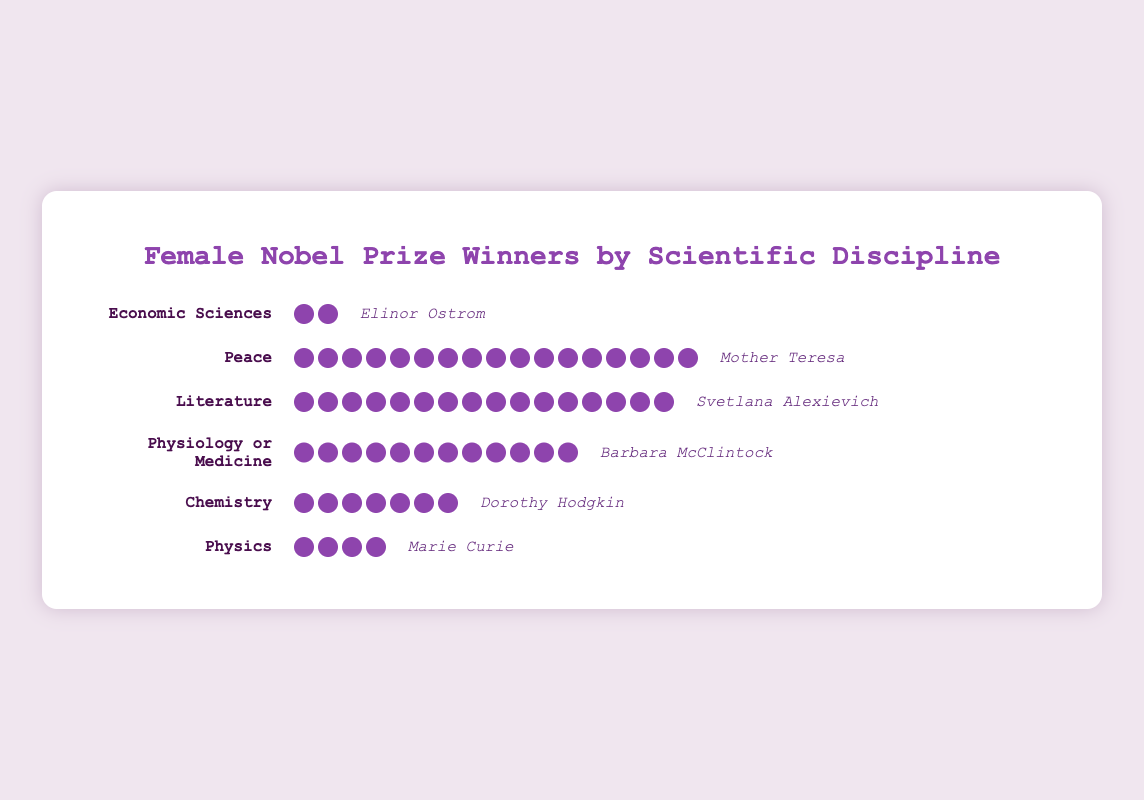What is the total number of female Nobel Prize winners in the category of Literature? Count the total number of icons in the Literature row.
Answer: 16 Which category has the least number of female Nobel Prize winners? Compare the number of icons in each category row and identify the one with the fewest icons.
Answer: Economic Sciences What is the difference in the number of female Nobel Prize winners between Peace and Physics categories? Count the number of icons in Peace (17) and Physics (4), then subtract the latter from the former. 17 - 4 = 13.
Answer: 13 How many more female Nobel Prize winners are there in Physiology or Medicine compared to Chemistry? Count the number of icons in Physiology or Medicine (12) and Chemistry (7), then subtract 7 from 12. 12 - 7 = 5.
Answer: 5 Who is the notable female figure in the category of Physics? Identify the name listed next to the Physics row under "notable-figure".
Answer: Marie Curie Which category has the most female Nobel Prize winners? Compare the number of icons in each category row and identify the one with the most icons.
Answer: Peace What is the combined total of female Nobel Prize winners in Chemistry and Economic Sciences categories? Count the number of icons in Chemistry (7) and Economic Sciences (2) and add them together. 7 + 2 = 9.
Answer: 9 If 3 more female Nobel Prize winners were added to the Physics category, how many would there be in total? Count the current number of icons in Physics (4) and then add 3. 4 + 3 = 7.
Answer: 7 Which category has more female Nobel Prize winners, Literature or Physiology or Medicine? Compare the number of icons in the Literature (16) and Physiology or Medicine (12) rows.
Answer: Literature Who is the notable figure associated with the highest number of female Nobel Prize winners? Identify the category with the most icons (Peace) and read the notable figure associated with it.
Answer: Mother Teresa 